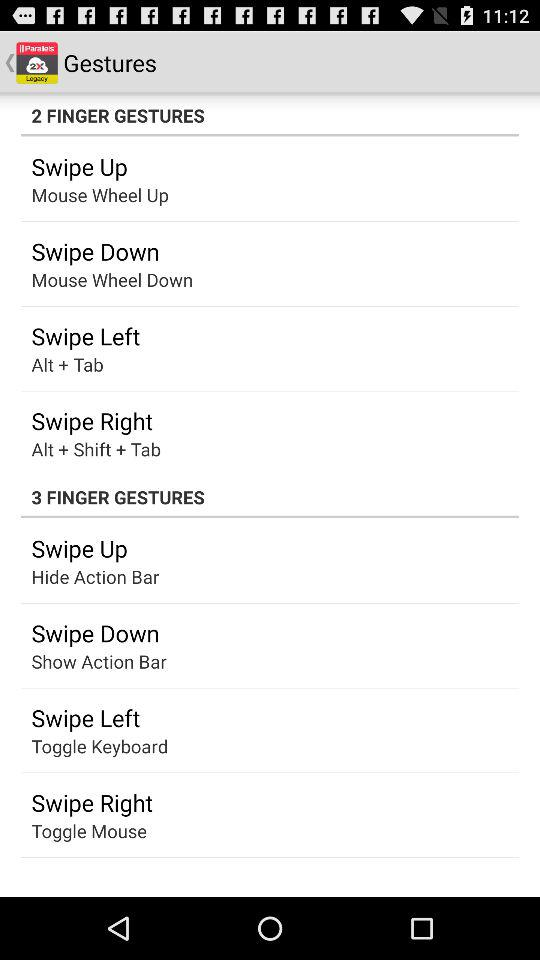In which gesture is the toggle mouse used for swiping right? The toggle mouse is used for swiping right in 3 finger gesture. 